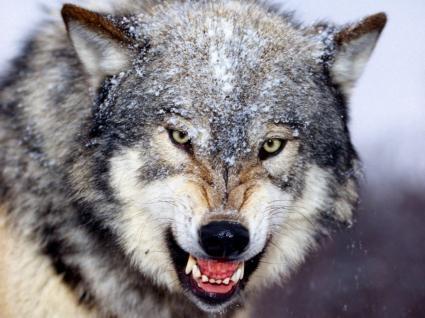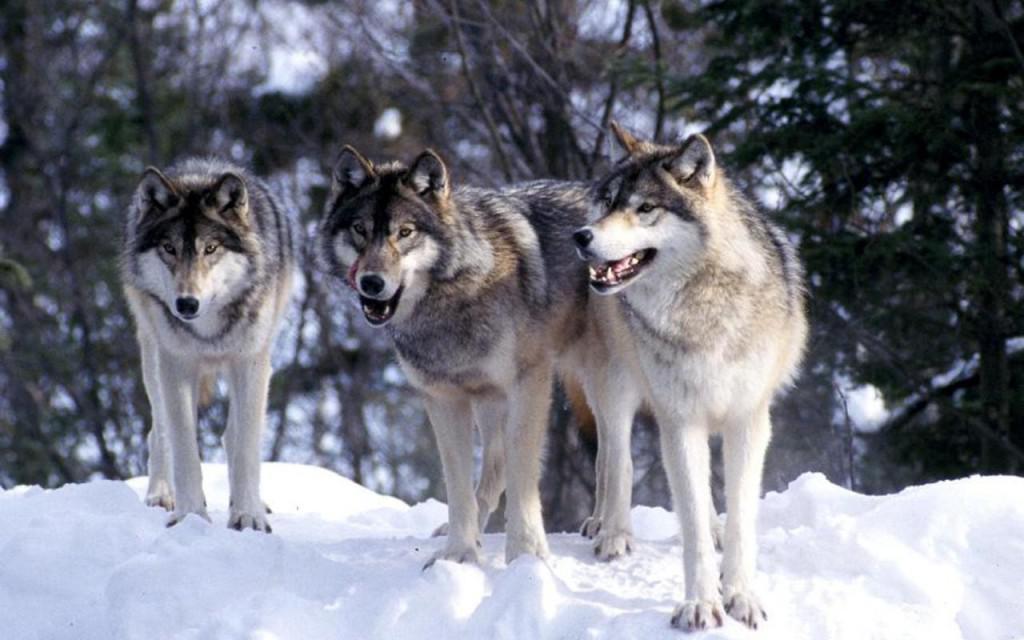The first image is the image on the left, the second image is the image on the right. For the images displayed, is the sentence "there are 4 wolves in the image pair" factually correct? Answer yes or no. Yes. The first image is the image on the left, the second image is the image on the right. For the images shown, is this caption "There are at least six wolves." true? Answer yes or no. No. 